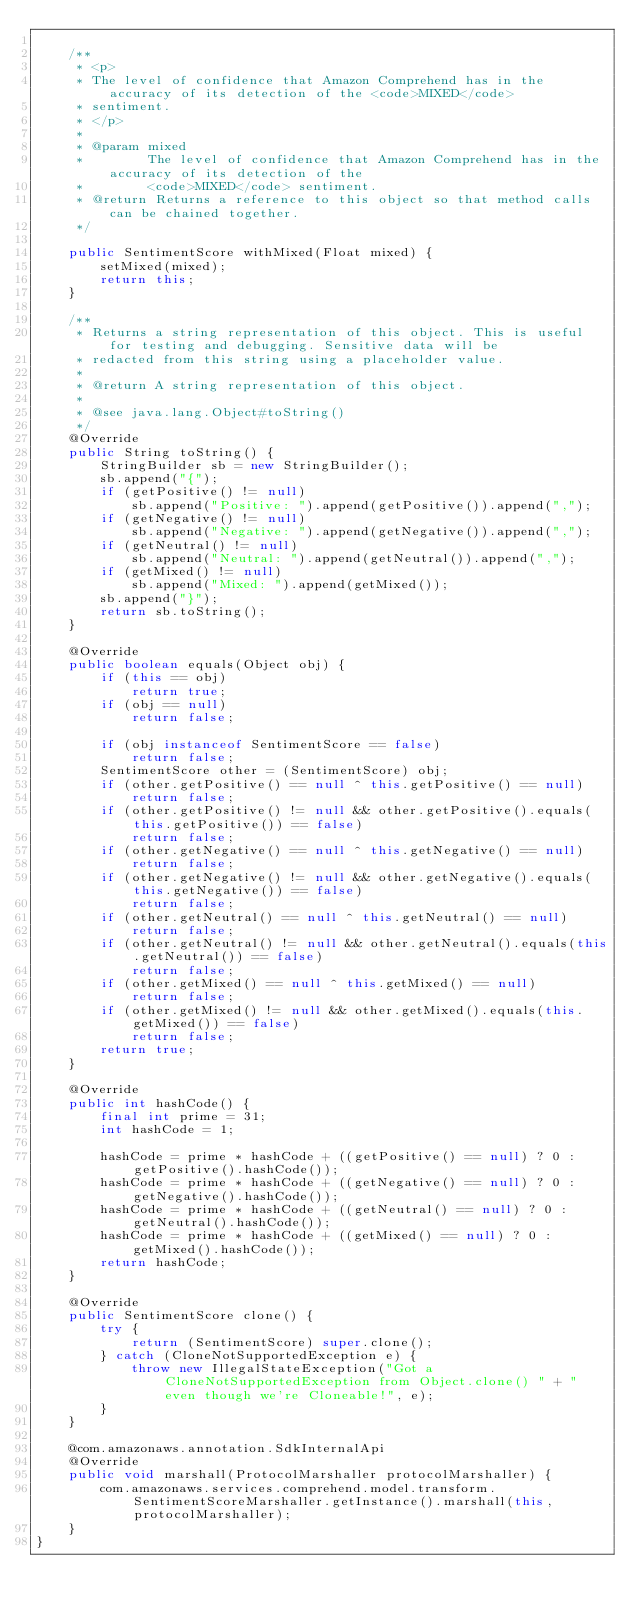<code> <loc_0><loc_0><loc_500><loc_500><_Java_>
    /**
     * <p>
     * The level of confidence that Amazon Comprehend has in the accuracy of its detection of the <code>MIXED</code>
     * sentiment.
     * </p>
     * 
     * @param mixed
     *        The level of confidence that Amazon Comprehend has in the accuracy of its detection of the
     *        <code>MIXED</code> sentiment.
     * @return Returns a reference to this object so that method calls can be chained together.
     */

    public SentimentScore withMixed(Float mixed) {
        setMixed(mixed);
        return this;
    }

    /**
     * Returns a string representation of this object. This is useful for testing and debugging. Sensitive data will be
     * redacted from this string using a placeholder value.
     *
     * @return A string representation of this object.
     *
     * @see java.lang.Object#toString()
     */
    @Override
    public String toString() {
        StringBuilder sb = new StringBuilder();
        sb.append("{");
        if (getPositive() != null)
            sb.append("Positive: ").append(getPositive()).append(",");
        if (getNegative() != null)
            sb.append("Negative: ").append(getNegative()).append(",");
        if (getNeutral() != null)
            sb.append("Neutral: ").append(getNeutral()).append(",");
        if (getMixed() != null)
            sb.append("Mixed: ").append(getMixed());
        sb.append("}");
        return sb.toString();
    }

    @Override
    public boolean equals(Object obj) {
        if (this == obj)
            return true;
        if (obj == null)
            return false;

        if (obj instanceof SentimentScore == false)
            return false;
        SentimentScore other = (SentimentScore) obj;
        if (other.getPositive() == null ^ this.getPositive() == null)
            return false;
        if (other.getPositive() != null && other.getPositive().equals(this.getPositive()) == false)
            return false;
        if (other.getNegative() == null ^ this.getNegative() == null)
            return false;
        if (other.getNegative() != null && other.getNegative().equals(this.getNegative()) == false)
            return false;
        if (other.getNeutral() == null ^ this.getNeutral() == null)
            return false;
        if (other.getNeutral() != null && other.getNeutral().equals(this.getNeutral()) == false)
            return false;
        if (other.getMixed() == null ^ this.getMixed() == null)
            return false;
        if (other.getMixed() != null && other.getMixed().equals(this.getMixed()) == false)
            return false;
        return true;
    }

    @Override
    public int hashCode() {
        final int prime = 31;
        int hashCode = 1;

        hashCode = prime * hashCode + ((getPositive() == null) ? 0 : getPositive().hashCode());
        hashCode = prime * hashCode + ((getNegative() == null) ? 0 : getNegative().hashCode());
        hashCode = prime * hashCode + ((getNeutral() == null) ? 0 : getNeutral().hashCode());
        hashCode = prime * hashCode + ((getMixed() == null) ? 0 : getMixed().hashCode());
        return hashCode;
    }

    @Override
    public SentimentScore clone() {
        try {
            return (SentimentScore) super.clone();
        } catch (CloneNotSupportedException e) {
            throw new IllegalStateException("Got a CloneNotSupportedException from Object.clone() " + "even though we're Cloneable!", e);
        }
    }

    @com.amazonaws.annotation.SdkInternalApi
    @Override
    public void marshall(ProtocolMarshaller protocolMarshaller) {
        com.amazonaws.services.comprehend.model.transform.SentimentScoreMarshaller.getInstance().marshall(this, protocolMarshaller);
    }
}
</code> 